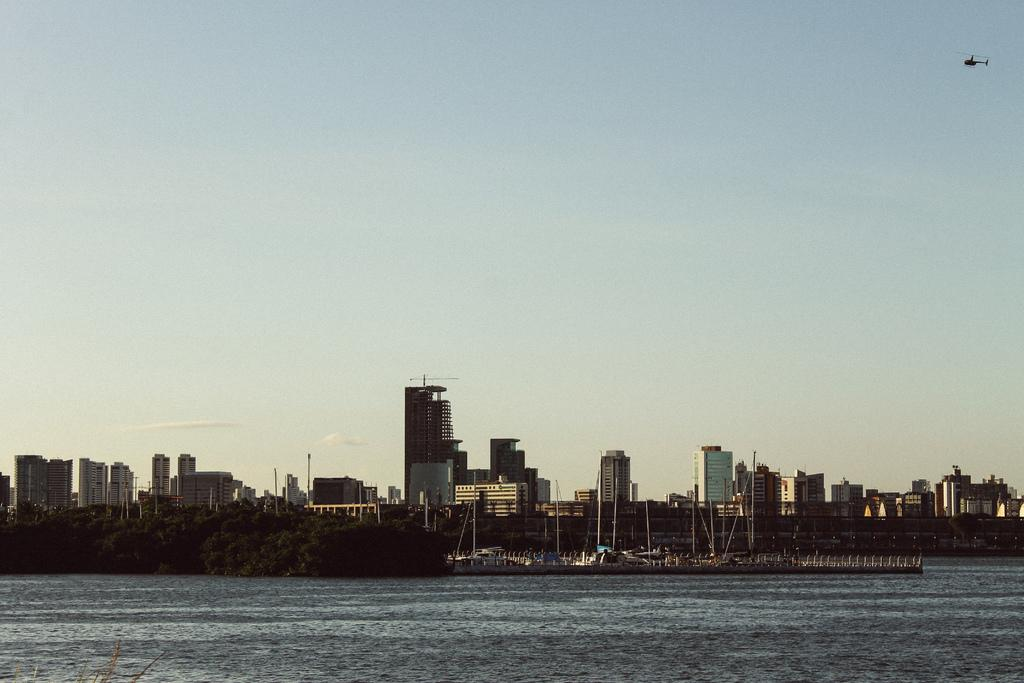What is the primary element visible in the image? There is water in the image. What can be seen in the background of the image? There are trees and buildings in the background of the image. Can you describe the object in the right top corner of the image? There is a helicopter in the right top corner of the image. What is the name of the person standing next to the water in the image? There is no person standing next to the water in the image. Can you see any cobwebs in the image? There are no cobwebs present in the image. 